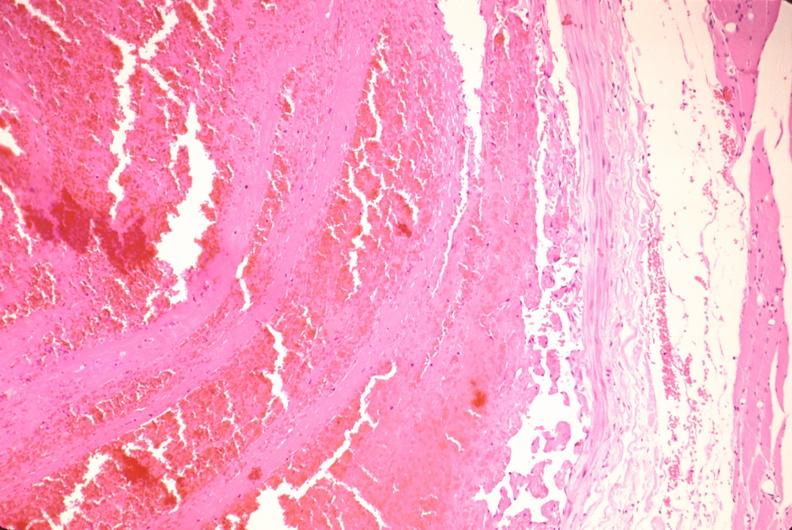where is this from?
Answer the question using a single word or phrase. Vasculature 